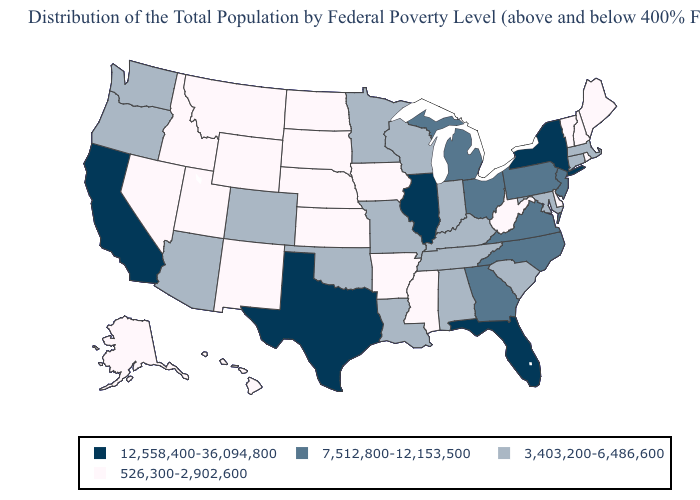Name the states that have a value in the range 7,512,800-12,153,500?
Concise answer only. Georgia, Michigan, New Jersey, North Carolina, Ohio, Pennsylvania, Virginia. What is the value of Georgia?
Keep it brief. 7,512,800-12,153,500. What is the value of Pennsylvania?
Short answer required. 7,512,800-12,153,500. Name the states that have a value in the range 7,512,800-12,153,500?
Answer briefly. Georgia, Michigan, New Jersey, North Carolina, Ohio, Pennsylvania, Virginia. Among the states that border New Hampshire , which have the lowest value?
Write a very short answer. Maine, Vermont. What is the value of Missouri?
Be succinct. 3,403,200-6,486,600. What is the lowest value in the USA?
Quick response, please. 526,300-2,902,600. How many symbols are there in the legend?
Give a very brief answer. 4. What is the lowest value in the USA?
Concise answer only. 526,300-2,902,600. What is the highest value in the USA?
Concise answer only. 12,558,400-36,094,800. What is the highest value in the Northeast ?
Write a very short answer. 12,558,400-36,094,800. What is the lowest value in the MidWest?
Quick response, please. 526,300-2,902,600. Name the states that have a value in the range 526,300-2,902,600?
Short answer required. Alaska, Arkansas, Delaware, Hawaii, Idaho, Iowa, Kansas, Maine, Mississippi, Montana, Nebraska, Nevada, New Hampshire, New Mexico, North Dakota, Rhode Island, South Dakota, Utah, Vermont, West Virginia, Wyoming. What is the lowest value in the Northeast?
Answer briefly. 526,300-2,902,600. What is the value of Kentucky?
Short answer required. 3,403,200-6,486,600. 